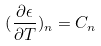<formula> <loc_0><loc_0><loc_500><loc_500>( \frac { \partial \epsilon } { \partial T } ) _ { n } = C _ { n }</formula> 